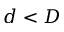<formula> <loc_0><loc_0><loc_500><loc_500>d < D</formula> 